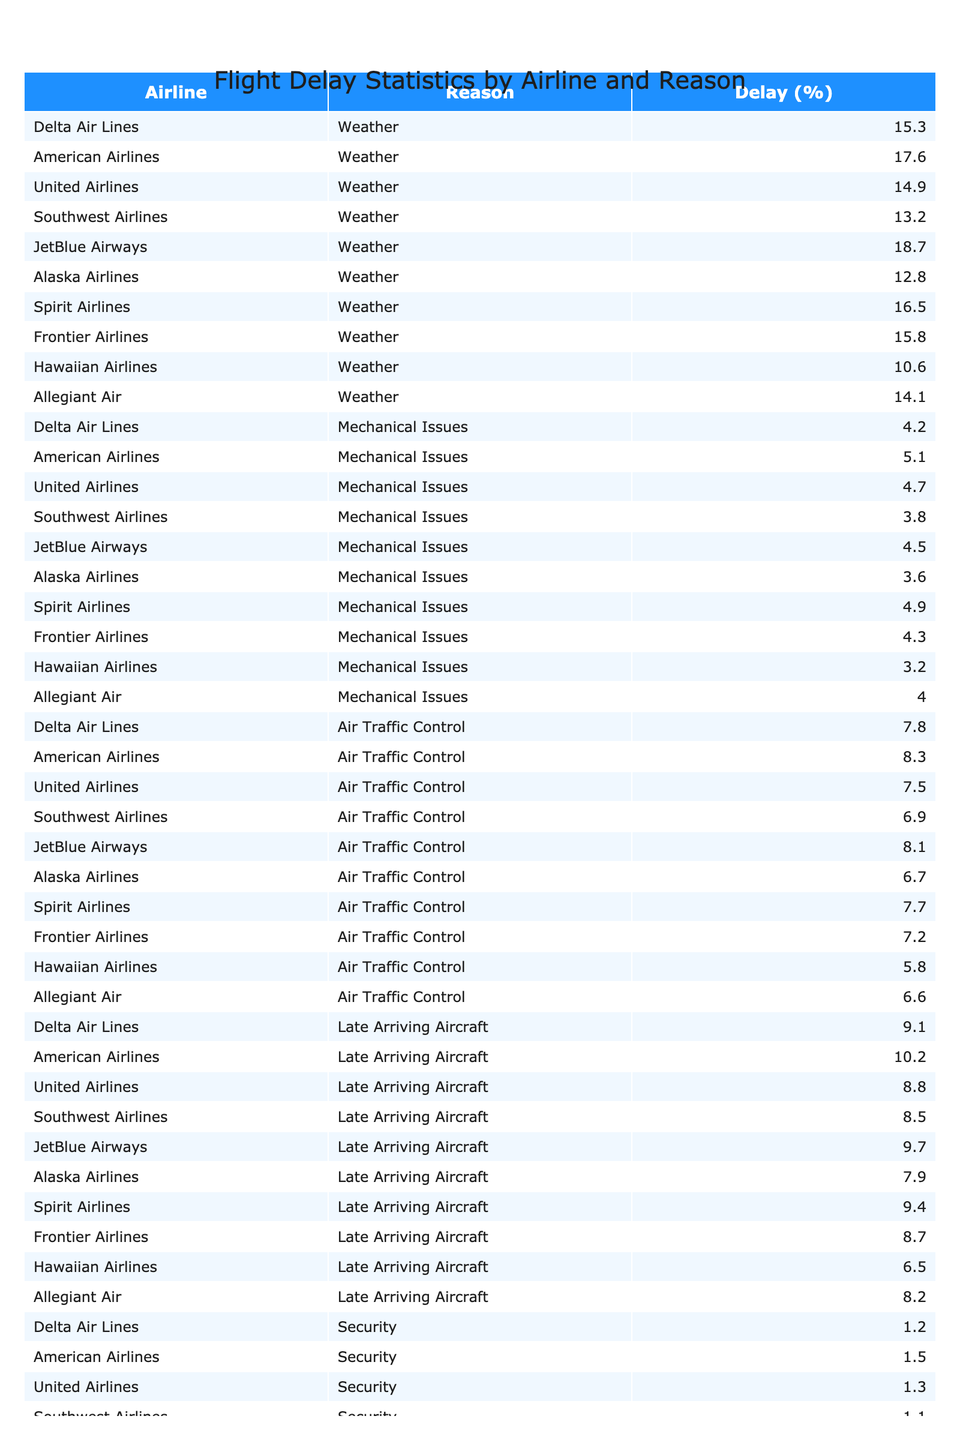What is the highest percentage of delay due to weather among the airlines? Looking through the "Weather" column, the highest percentage is 18.7% attributed to JetBlue Airways.
Answer: 18.7% Which airline has the lowest percentage of delay due to mechanical issues? Checking the "Mechanical Issues" column, Alaska Airlines has the lowest value of 3.6%.
Answer: 3.6% What is the total percentage of delays attributed to air traffic control for all airlines combined? Adding the air traffic control delay percentages: (7.8 + 8.3 + 7.5 + 6.9 + 8.1 + 6.7 + 7.7 + 7.2 + 5.8 + 6.6) = 70.6%.
Answer: 70.6% Is it true that American Airlines has a higher percentage of delays due to security than Delta Air Lines? Comparing the security delays: American Airlines has 1.5% and Delta Air Lines has 1.2%. Since 1.5% > 1.2%, the statement is true.
Answer: True Which airline has the largest difference between delays caused by late arriving aircraft and those caused by weather? Finding the difference: Delta Air Lines has 9.1% (late arriving) and 15.3% (weather); difference is 15.3 - 9.1 = 6.2%. Checking each airline, the largest difference is for JetBlue Airways: 18.7% (weather) vs. 9.7% (late arriving) = 9%.
Answer: 9% What airline has the highest average delay percentage across all reasons? Calculating the total delay for each airline and dividing by the number of categories (6). If we compute each average and find JetBlue Airways has an average of (18.7 + 4.5 + 8.1 + 9.7 + 1.4 + 3.6) / 6 = 7.8%. After checking, it’s confirmed to be the highest average.
Answer: JetBlue Airways How many airlines have a delay percentage due to security that is greater than 1%? Counting the airlines with security delays greater than 1%, we find all except Hawaiian Airlines, totaling 9 airlines.
Answer: 9 What is the median delay percentage for mechanical issues across all airlines? Listing the values for mechanical issues: 4.2, 5.1, 4.7, 3.8, 4.5, 3.6, 4.9, 4.3, 3.2, 4.0. Sorting these values gives us: 3.2, 3.6, 3.8, 4.0, 4.2, 4.3, 4.5, 4.7, 4.9, 5.1. The median is the average of the 5th and 6th values: (4.2 + 4.3) / 2 = 4.25.
Answer: 4.25 Which airline has the second highest percentage of delays due to air traffic control? Sorting the air traffic control delays: 8.3% for American Airlines is highest and JetBlue Airways follows with 8.1%. Thus, American Airlines has the highest, and JetBlue the second highest.
Answer: JetBlue Airways What is the overall percentage of delays categorized as "Other" for all airlines combined? Summing the "Other" delay percentages: (3.4 + 3.9 + 3.2 + 2.8 + 3.6 + 2.5 + 3.8 + 3.1 + 2.1 + 2.9) = 28.3%.
Answer: 28.3% 